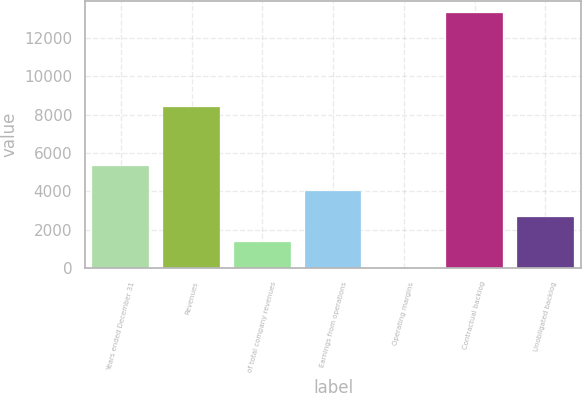Convert chart. <chart><loc_0><loc_0><loc_500><loc_500><bar_chart><fcel>Years ended December 31<fcel>Revenues<fcel>of total company revenues<fcel>Earnings from operations<fcel>Operating margins<fcel>Contractual backlog<fcel>Unobligated backlog<nl><fcel>5325.3<fcel>8427<fcel>1339.95<fcel>3996.85<fcel>11.5<fcel>13296<fcel>2668.4<nl></chart> 